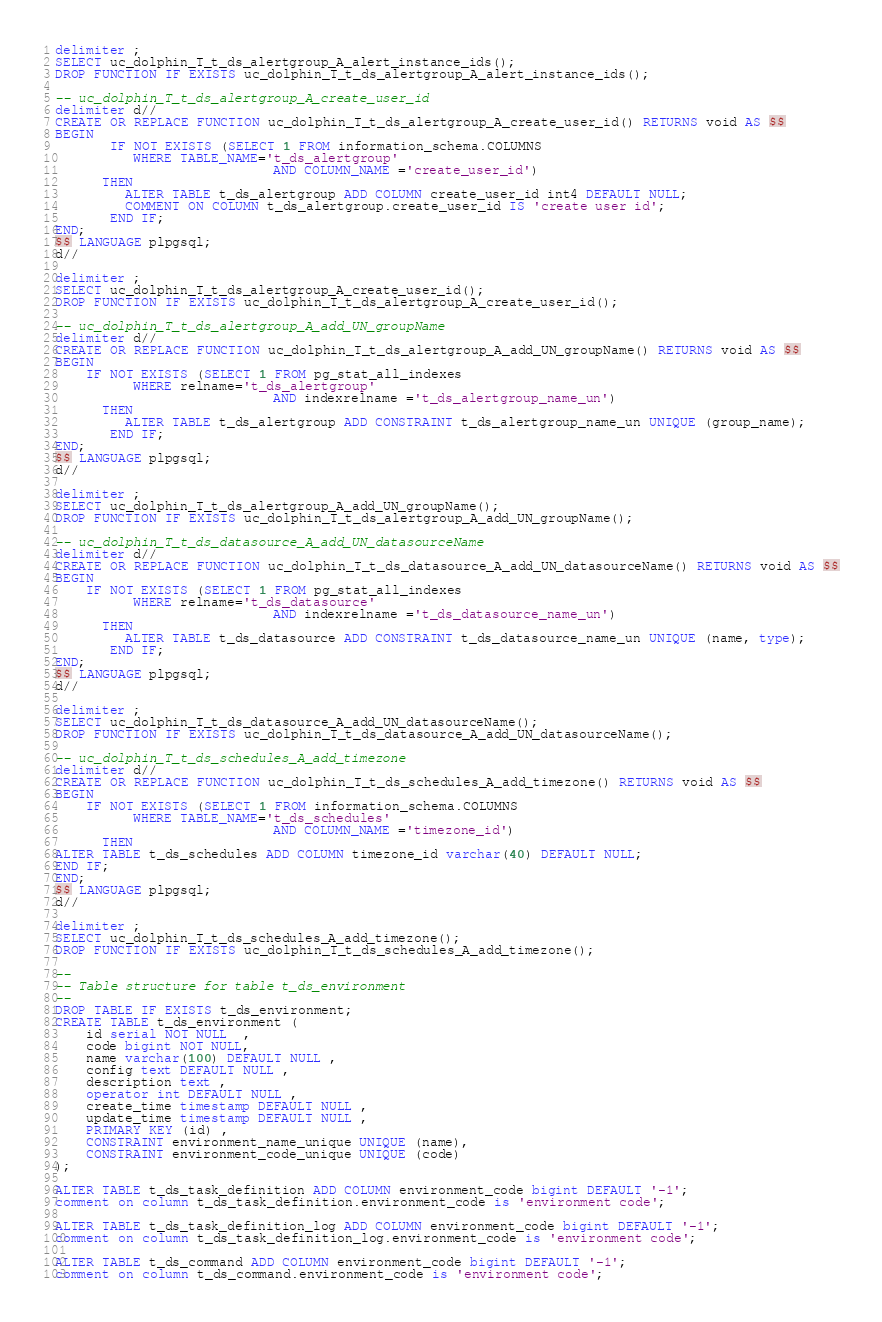<code> <loc_0><loc_0><loc_500><loc_500><_SQL_>delimiter ;
SELECT uc_dolphin_T_t_ds_alertgroup_A_alert_instance_ids();
DROP FUNCTION IF EXISTS uc_dolphin_T_t_ds_alertgroup_A_alert_instance_ids();

-- uc_dolphin_T_t_ds_alertgroup_A_create_user_id
delimiter d//
CREATE OR REPLACE FUNCTION uc_dolphin_T_t_ds_alertgroup_A_create_user_id() RETURNS void AS $$
BEGIN
       IF NOT EXISTS (SELECT 1 FROM information_schema.COLUMNS
          WHERE TABLE_NAME='t_ds_alertgroup'
                            AND COLUMN_NAME ='create_user_id')
      THEN
         ALTER TABLE t_ds_alertgroup ADD COLUMN create_user_id int4 DEFAULT NULL;
         COMMENT ON COLUMN t_ds_alertgroup.create_user_id IS 'create user id';
       END IF;
END;
$$ LANGUAGE plpgsql;
d//

delimiter ;
SELECT uc_dolphin_T_t_ds_alertgroup_A_create_user_id();
DROP FUNCTION IF EXISTS uc_dolphin_T_t_ds_alertgroup_A_create_user_id();

-- uc_dolphin_T_t_ds_alertgroup_A_add_UN_groupName
delimiter d//
CREATE OR REPLACE FUNCTION uc_dolphin_T_t_ds_alertgroup_A_add_UN_groupName() RETURNS void AS $$
BEGIN
    IF NOT EXISTS (SELECT 1 FROM pg_stat_all_indexes
          WHERE relname='t_ds_alertgroup'
                            AND indexrelname ='t_ds_alertgroup_name_un')
      THEN
         ALTER TABLE t_ds_alertgroup ADD CONSTRAINT t_ds_alertgroup_name_un UNIQUE (group_name);
       END IF;
END;
$$ LANGUAGE plpgsql;
d//

delimiter ;
SELECT uc_dolphin_T_t_ds_alertgroup_A_add_UN_groupName();
DROP FUNCTION IF EXISTS uc_dolphin_T_t_ds_alertgroup_A_add_UN_groupName();

-- uc_dolphin_T_t_ds_datasource_A_add_UN_datasourceName
delimiter d//
CREATE OR REPLACE FUNCTION uc_dolphin_T_t_ds_datasource_A_add_UN_datasourceName() RETURNS void AS $$
BEGIN
    IF NOT EXISTS (SELECT 1 FROM pg_stat_all_indexes
          WHERE relname='t_ds_datasource'
                            AND indexrelname ='t_ds_datasource_name_un')
      THEN
         ALTER TABLE t_ds_datasource ADD CONSTRAINT t_ds_datasource_name_un UNIQUE (name, type);
       END IF;
END;
$$ LANGUAGE plpgsql;
d//

delimiter ;
SELECT uc_dolphin_T_t_ds_datasource_A_add_UN_datasourceName();
DROP FUNCTION IF EXISTS uc_dolphin_T_t_ds_datasource_A_add_UN_datasourceName();

-- uc_dolphin_T_t_ds_schedules_A_add_timezone
delimiter d//
CREATE OR REPLACE FUNCTION uc_dolphin_T_t_ds_schedules_A_add_timezone() RETURNS void AS $$
BEGIN
    IF NOT EXISTS (SELECT 1 FROM information_schema.COLUMNS
          WHERE TABLE_NAME='t_ds_schedules'
                            AND COLUMN_NAME ='timezone_id')
      THEN
ALTER TABLE t_ds_schedules ADD COLUMN timezone_id varchar(40) DEFAULT NULL;
END IF;
END;
$$ LANGUAGE plpgsql;
d//

delimiter ;
SELECT uc_dolphin_T_t_ds_schedules_A_add_timezone();
DROP FUNCTION IF EXISTS uc_dolphin_T_t_ds_schedules_A_add_timezone();

--
-- Table structure for table t_ds_environment
--
DROP TABLE IF EXISTS t_ds_environment;
CREATE TABLE t_ds_environment (
    id serial NOT NULL  ,
    code bigint NOT NULL,
    name varchar(100) DEFAULT NULL ,
    config text DEFAULT NULL ,
    description text ,
    operator int DEFAULT NULL ,
    create_time timestamp DEFAULT NULL ,
    update_time timestamp DEFAULT NULL ,
    PRIMARY KEY (id) ,
    CONSTRAINT environment_name_unique UNIQUE (name),
    CONSTRAINT environment_code_unique UNIQUE (code)
);

ALTER TABLE t_ds_task_definition ADD COLUMN environment_code bigint DEFAULT '-1';
comment on column t_ds_task_definition.environment_code is 'environment code';

ALTER TABLE t_ds_task_definition_log ADD COLUMN environment_code bigint DEFAULT '-1';
comment on column t_ds_task_definition_log.environment_code is 'environment code';

ALTER TABLE t_ds_command ADD COLUMN environment_code bigint DEFAULT '-1';
comment on column t_ds_command.environment_code is 'environment code';
</code> 